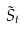<formula> <loc_0><loc_0><loc_500><loc_500>\tilde { S } _ { t }</formula> 